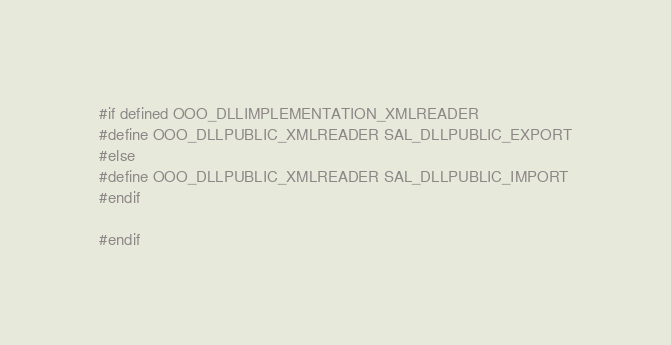Convert code to text. <code><loc_0><loc_0><loc_500><loc_500><_C++_>
#if defined OOO_DLLIMPLEMENTATION_XMLREADER
#define OOO_DLLPUBLIC_XMLREADER SAL_DLLPUBLIC_EXPORT
#else
#define OOO_DLLPUBLIC_XMLREADER SAL_DLLPUBLIC_IMPORT
#endif

#endif
</code> 